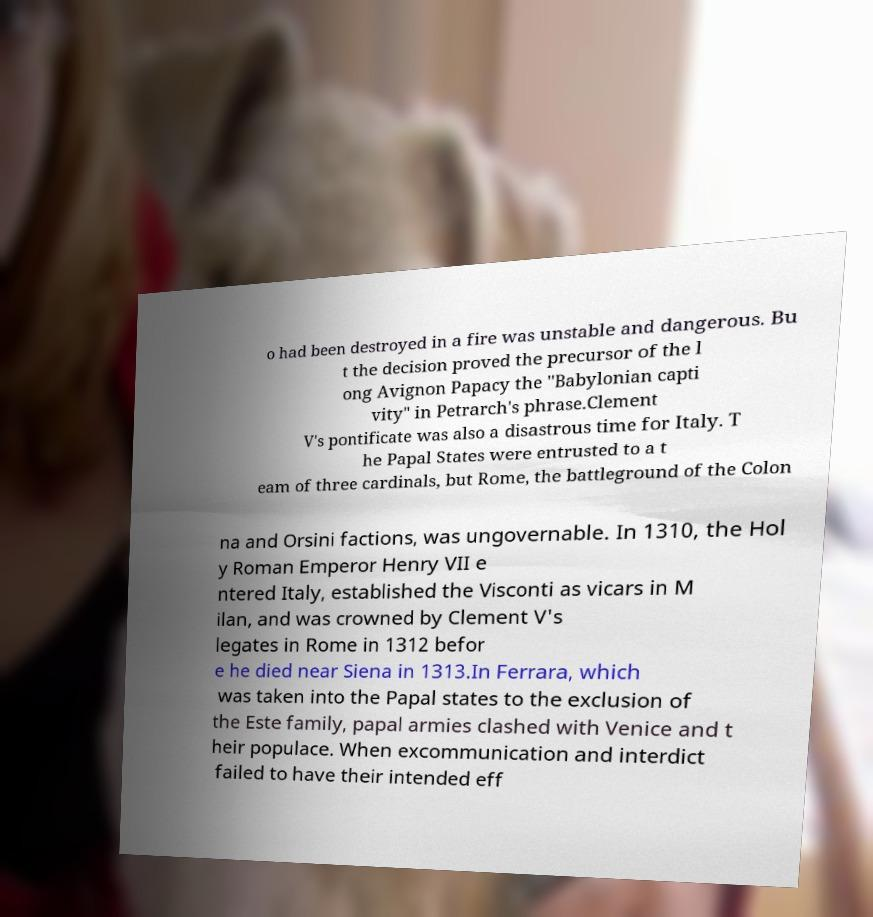Can you accurately transcribe the text from the provided image for me? o had been destroyed in a fire was unstable and dangerous. Bu t the decision proved the precursor of the l ong Avignon Papacy the "Babylonian capti vity" in Petrarch's phrase.Clement V's pontificate was also a disastrous time for Italy. T he Papal States were entrusted to a t eam of three cardinals, but Rome, the battleground of the Colon na and Orsini factions, was ungovernable. In 1310, the Hol y Roman Emperor Henry VII e ntered Italy, established the Visconti as vicars in M ilan, and was crowned by Clement V's legates in Rome in 1312 befor e he died near Siena in 1313.In Ferrara, which was taken into the Papal states to the exclusion of the Este family, papal armies clashed with Venice and t heir populace. When excommunication and interdict failed to have their intended eff 